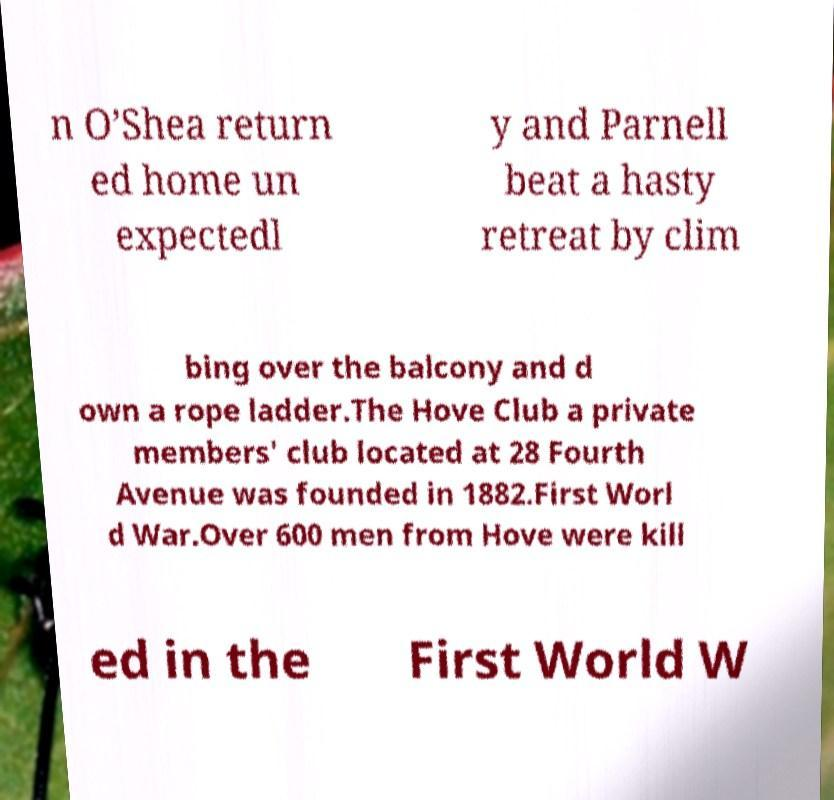Please read and relay the text visible in this image. What does it say? n O’Shea return ed home un expectedl y and Parnell beat a hasty retreat by clim bing over the balcony and d own a rope ladder.The Hove Club a private members' club located at 28 Fourth Avenue was founded in 1882.First Worl d War.Over 600 men from Hove were kill ed in the First World W 